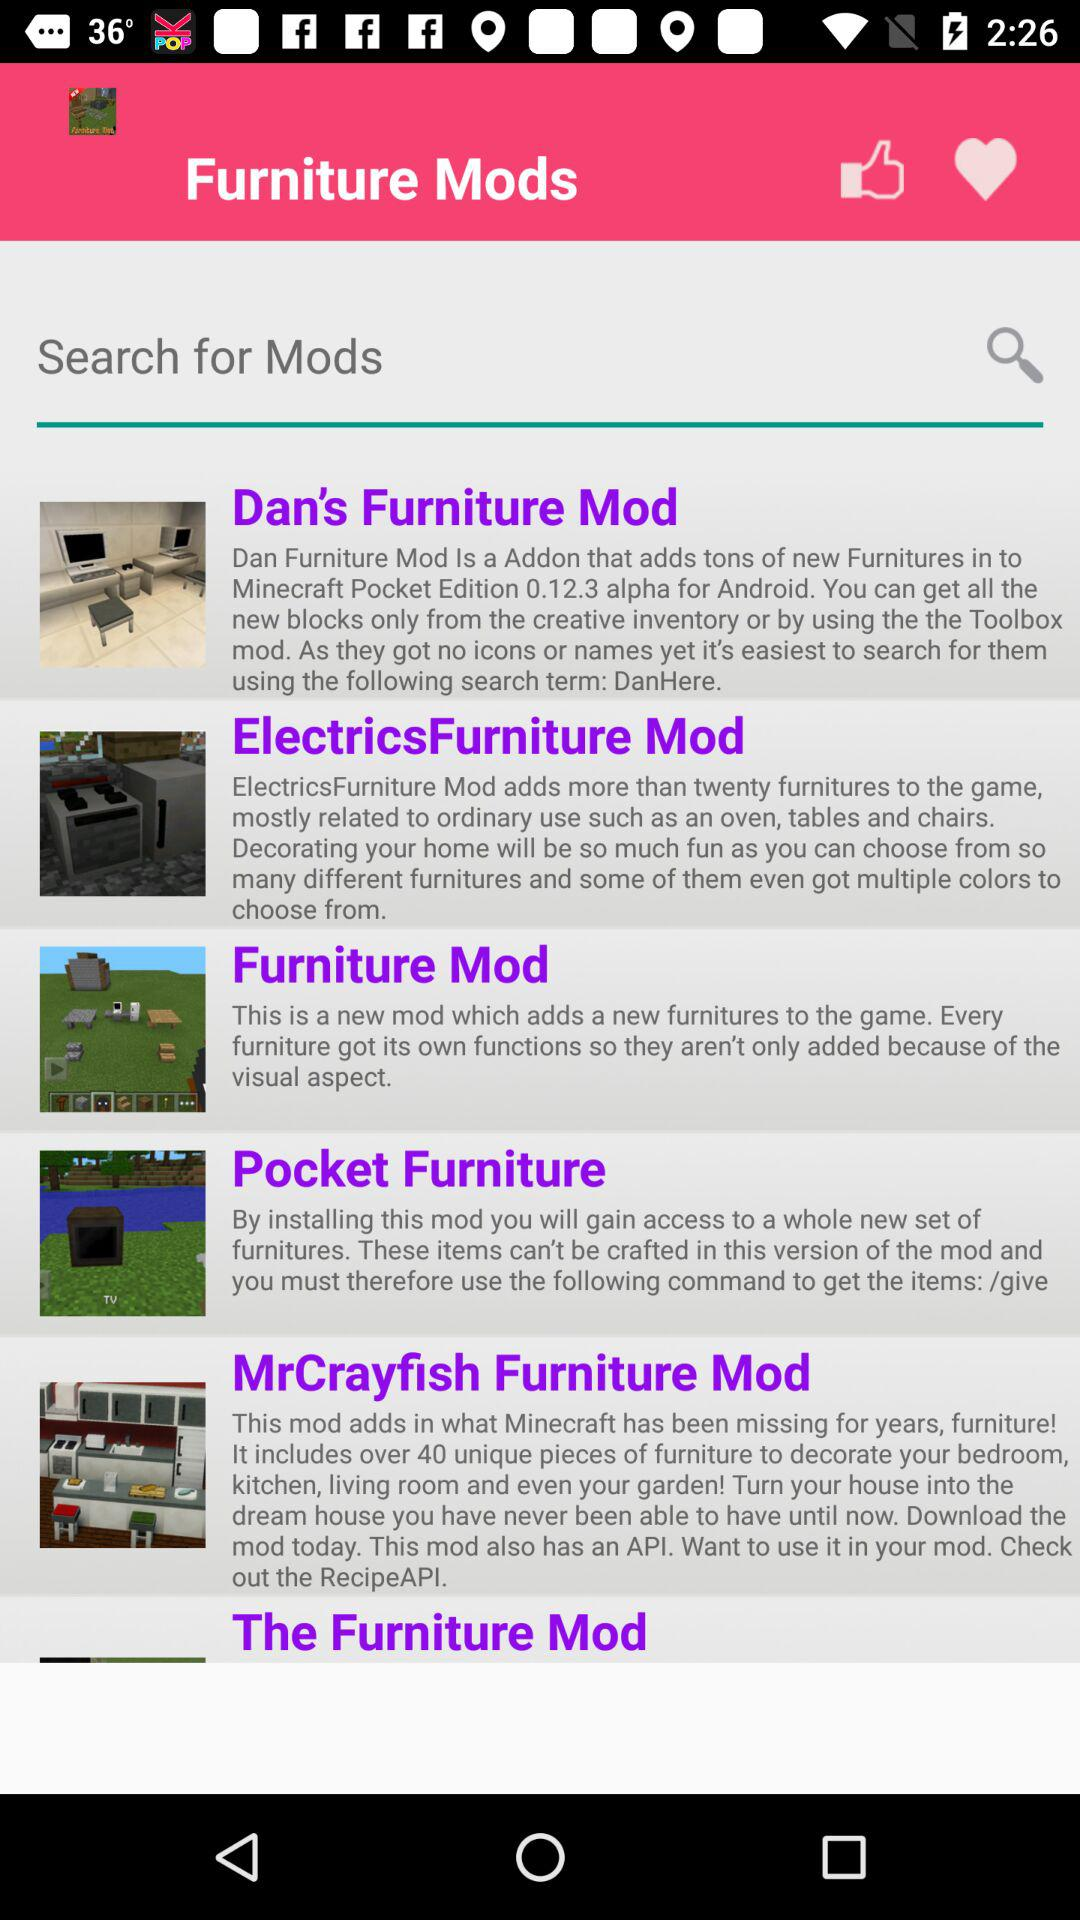Which furniture mod adds more than twenty pieces of furniture to the game? The mod is "ElectronicsFurniture". 